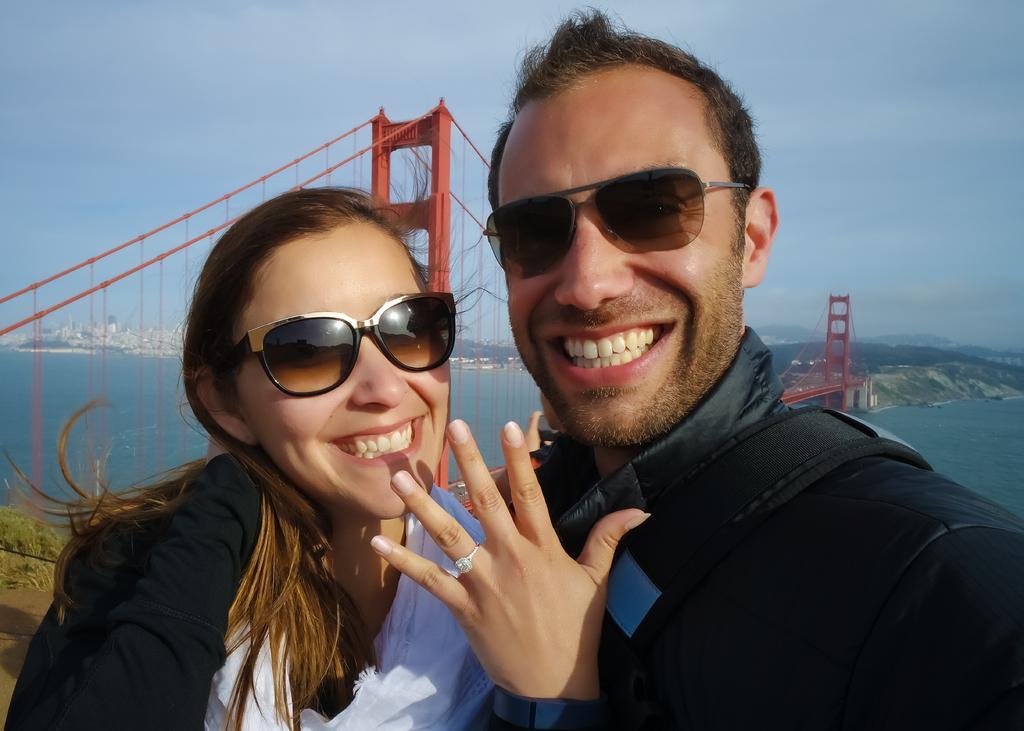Describe this image in one or two sentences. In this image I can see two people standing and smiling. Back I can see a red color bridge,water and buildings. The sky is in white and blue color. 